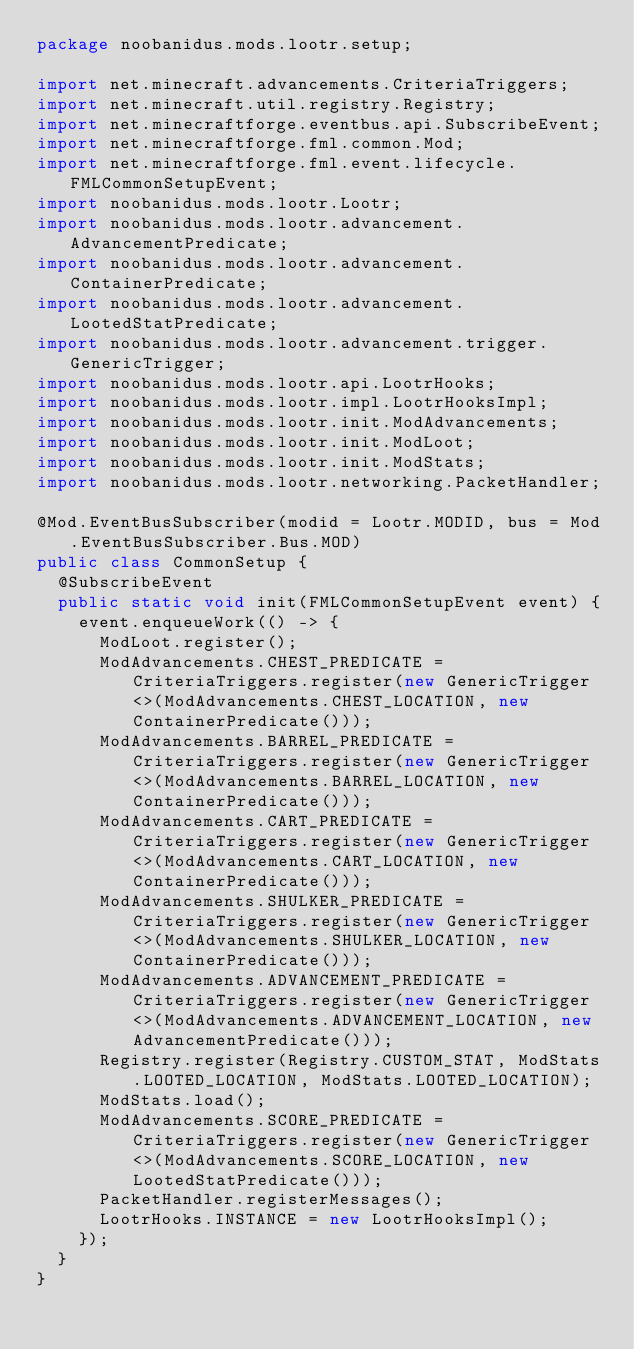Convert code to text. <code><loc_0><loc_0><loc_500><loc_500><_Java_>package noobanidus.mods.lootr.setup;

import net.minecraft.advancements.CriteriaTriggers;
import net.minecraft.util.registry.Registry;
import net.minecraftforge.eventbus.api.SubscribeEvent;
import net.minecraftforge.fml.common.Mod;
import net.minecraftforge.fml.event.lifecycle.FMLCommonSetupEvent;
import noobanidus.mods.lootr.Lootr;
import noobanidus.mods.lootr.advancement.AdvancementPredicate;
import noobanidus.mods.lootr.advancement.ContainerPredicate;
import noobanidus.mods.lootr.advancement.LootedStatPredicate;
import noobanidus.mods.lootr.advancement.trigger.GenericTrigger;
import noobanidus.mods.lootr.api.LootrHooks;
import noobanidus.mods.lootr.impl.LootrHooksImpl;
import noobanidus.mods.lootr.init.ModAdvancements;
import noobanidus.mods.lootr.init.ModLoot;
import noobanidus.mods.lootr.init.ModStats;
import noobanidus.mods.lootr.networking.PacketHandler;

@Mod.EventBusSubscriber(modid = Lootr.MODID, bus = Mod.EventBusSubscriber.Bus.MOD)
public class CommonSetup {
  @SubscribeEvent
  public static void init(FMLCommonSetupEvent event) {
    event.enqueueWork(() -> {
      ModLoot.register();
      ModAdvancements.CHEST_PREDICATE = CriteriaTriggers.register(new GenericTrigger<>(ModAdvancements.CHEST_LOCATION, new ContainerPredicate()));
      ModAdvancements.BARREL_PREDICATE = CriteriaTriggers.register(new GenericTrigger<>(ModAdvancements.BARREL_LOCATION, new ContainerPredicate()));
      ModAdvancements.CART_PREDICATE = CriteriaTriggers.register(new GenericTrigger<>(ModAdvancements.CART_LOCATION, new ContainerPredicate()));
      ModAdvancements.SHULKER_PREDICATE = CriteriaTriggers.register(new GenericTrigger<>(ModAdvancements.SHULKER_LOCATION, new ContainerPredicate()));
      ModAdvancements.ADVANCEMENT_PREDICATE = CriteriaTriggers.register(new GenericTrigger<>(ModAdvancements.ADVANCEMENT_LOCATION, new AdvancementPredicate()));
      Registry.register(Registry.CUSTOM_STAT, ModStats.LOOTED_LOCATION, ModStats.LOOTED_LOCATION);
      ModStats.load();
      ModAdvancements.SCORE_PREDICATE = CriteriaTriggers.register(new GenericTrigger<>(ModAdvancements.SCORE_LOCATION, new LootedStatPredicate()));
      PacketHandler.registerMessages();
      LootrHooks.INSTANCE = new LootrHooksImpl();
    });
  }
}
</code> 